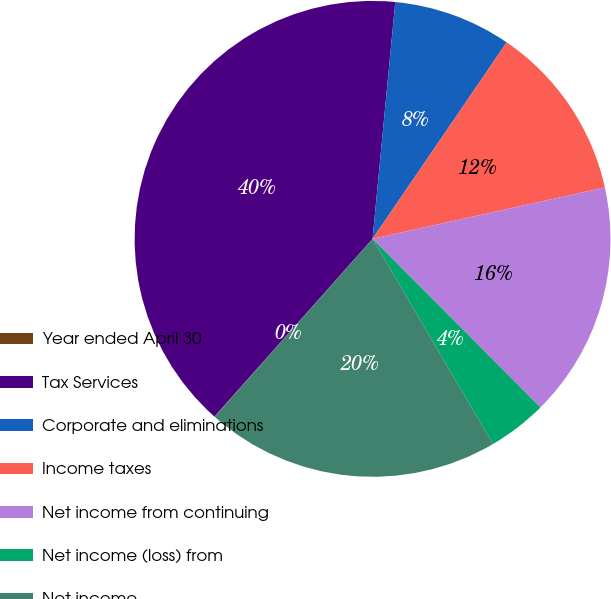Convert chart to OTSL. <chart><loc_0><loc_0><loc_500><loc_500><pie_chart><fcel>Year ended April 30<fcel>Tax Services<fcel>Corporate and eliminations<fcel>Income taxes<fcel>Net income from continuing<fcel>Net income (loss) from<fcel>Net income<nl><fcel>0.03%<fcel>39.95%<fcel>8.01%<fcel>12.0%<fcel>16.0%<fcel>4.02%<fcel>19.99%<nl></chart> 